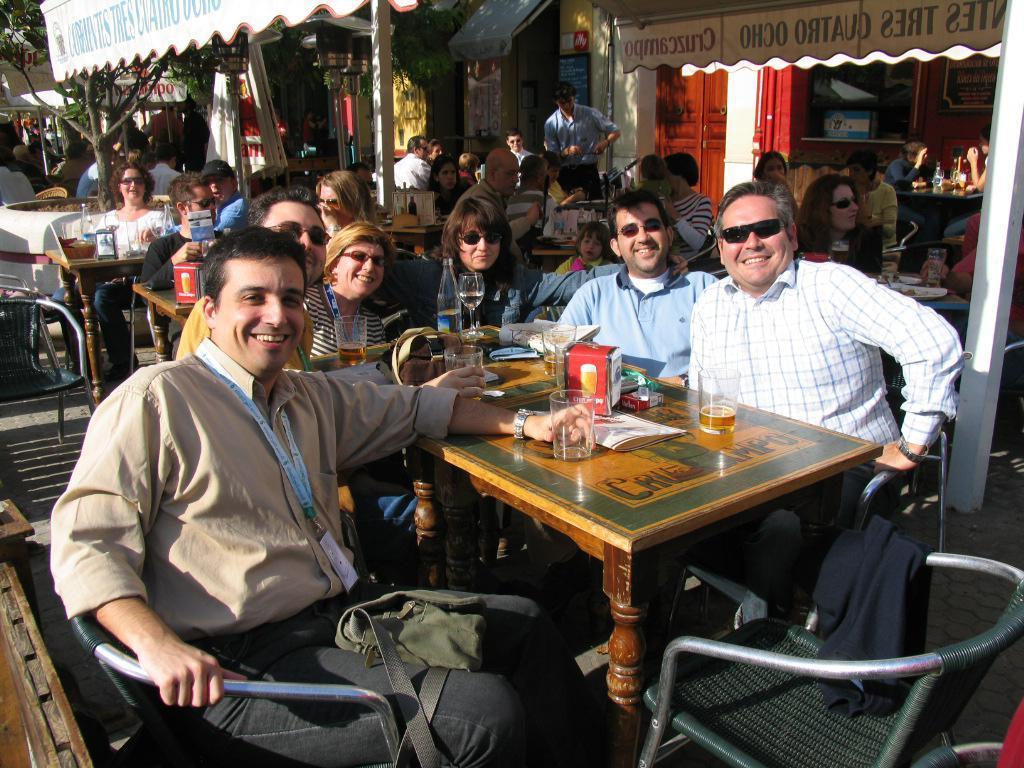Could you give a brief overview of what you see in this image? In this picture there are group of people sitting and holding a wine glass in their hands 